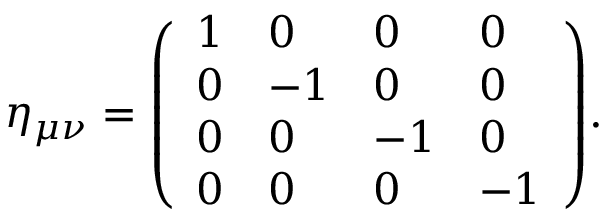Convert formula to latex. <formula><loc_0><loc_0><loc_500><loc_500>\eta _ { \mu \nu } = { \left ( \begin{array} { l l l l } { 1 } & { 0 } & { 0 } & { 0 } \\ { 0 } & { - 1 } & { 0 } & { 0 } \\ { 0 } & { 0 } & { - 1 } & { 0 } \\ { 0 } & { 0 } & { 0 } & { - 1 } \end{array} \right ) } .</formula> 